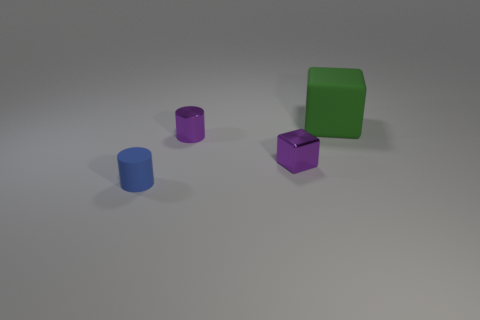What is the shape of the small shiny object that is the same color as the tiny cube?
Keep it short and to the point. Cylinder. Are there more big yellow matte cylinders than big things?
Keep it short and to the point. No. There is a tiny purple thing that is the same shape as the green matte thing; what is it made of?
Your answer should be very brief. Metal. Is the purple block made of the same material as the big green object?
Keep it short and to the point. No. Are there more shiny cylinders that are in front of the tiny blue cylinder than big red metal spheres?
Your response must be concise. No. The block that is in front of the matte thing that is right of the small cylinder that is in front of the small metallic cube is made of what material?
Provide a short and direct response. Metal. How many things are big matte balls or cubes left of the green rubber block?
Make the answer very short. 1. Is the color of the metal object right of the purple metal cylinder the same as the large matte block?
Offer a terse response. No. Are there more large matte blocks behind the large green block than blue things that are on the left side of the tiny rubber thing?
Your answer should be very brief. No. Are there any other things that are the same color as the large rubber thing?
Ensure brevity in your answer.  No. 